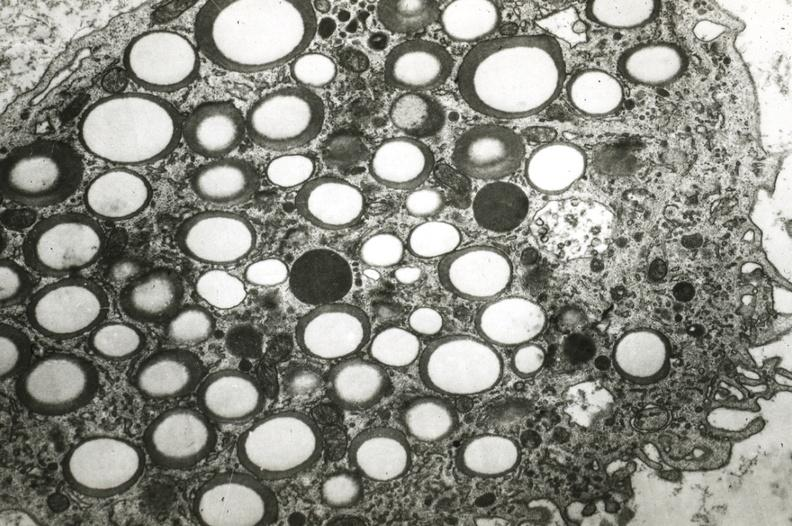s cardiovascular present?
Answer the question using a single word or phrase. Yes 